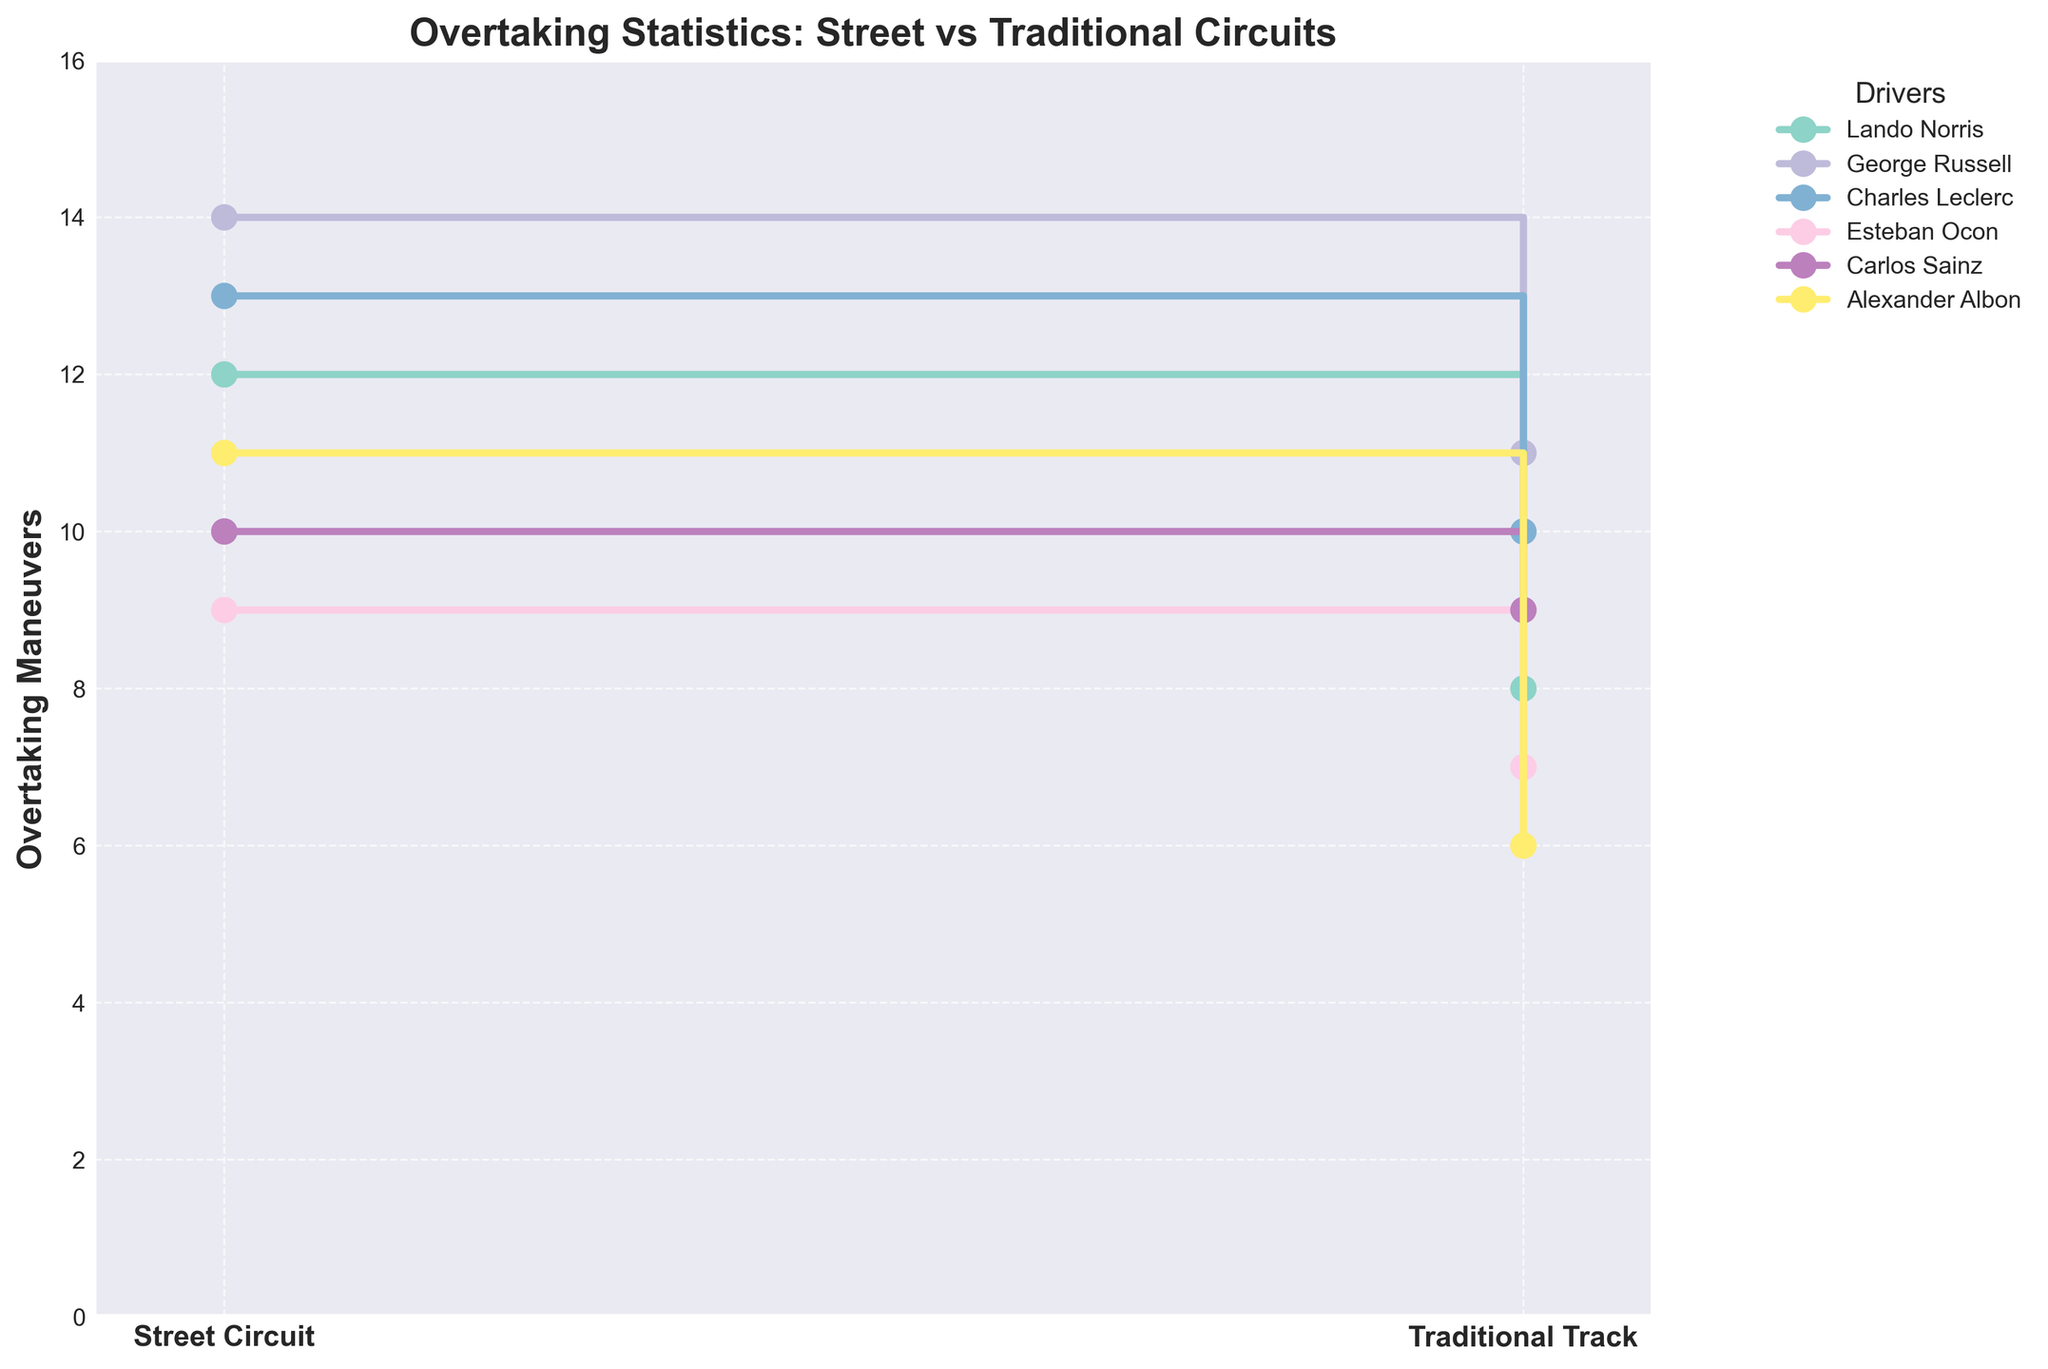What's the title of the figure? The title is typically prominently displayed at the top of the figure. In this case, it provides an overview of what the plot represents.
Answer: Overtaking Statistics: Street vs Traditional Circuits Which driver has the highest number of overtaking maneuvers on street circuits? Look for the driver whose step plot reaches the highest value on the y-axis for street circuits.
Answer: George Russell How many more overtaking maneuvers does Alexander Albon have on street circuits compared to traditional tracks? Subtract the number of overtaking maneuvers on traditional tracks from those on street circuits for Alexander Albon. (11 - 6 = 5)
Answer: 5 Which driver shows the smallest difference in overtaking maneuvers between street circuits and traditional tracks? Calculate the difference between the two types of circuits for each driver and identify the smallest value. For example, Lando Norris has a difference of (12 - 8 = 4). Repeating this for all, Carlos Sainz has a difference of (10 - 9 = 1).
Answer: Carlos Sainz Arrange the drivers in descending order of overtaking maneuvers on traditional tracks. Reference the values for traditional tracks and list the drivers in order from highest to lowest maneuvers. This involves George Russell (11), Charles Leclerc (10), Carlos Sainz (9), Lando Norris (8), Esteban Ocon (7), Alexander Albon (6).
Answer: George Russell, Charles Leclerc, Carlos Sainz, Lando Norris, Esteban Ocon, Alexander Albon Who has overtaken more on street circuits, Lando Norris or Esteban Ocon? Compare the values representing the overtaking maneuvers on street circuits for both drivers. (Lando Norris: 12, Esteban Ocon: 9)
Answer: Lando Norris By what percent did Charles Leclerc's overtaking maneuvers decrease from street circuits to traditional tracks? Calculate the decrease from street circuits (13) to traditional tracks (10) for Charles Leclerc, then find the percentage decrease ((13-10)/13 * 100 = 23.08%).
Answer: 23.08% Which driver shows an increase in overtaking maneuvers when moving from traditional tracks to street circuits? Check if there are drivers with a positive difference when comparing street circuits to traditional tracks' values. All drivers have higher overtaking maneuvers on street circuits than traditional tracks, so all drivers qualify.
Answer: All drivers What’s the combined number of overtaking maneuvers for Carlos Sainz across both types of circuits? Add the overtaking maneuvers on street circuits (10) and traditional tracks (9) for Carlos Sainz (10 + 9 = 19).
Answer: 19 Is the increase in overtaking maneuvers on street circuits compared to traditional tracks consistent across all drivers? Compare each driver's overtaking numbers on both types of circuits; each has a higher value on street circuits.
Answer: Yes 